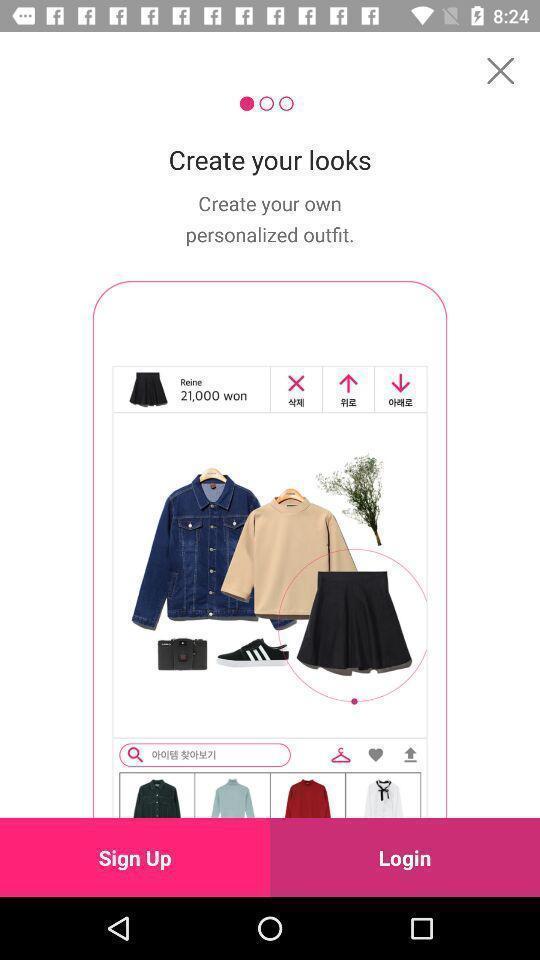Summarize the main components in this picture. Welcome page in a shopping app. 